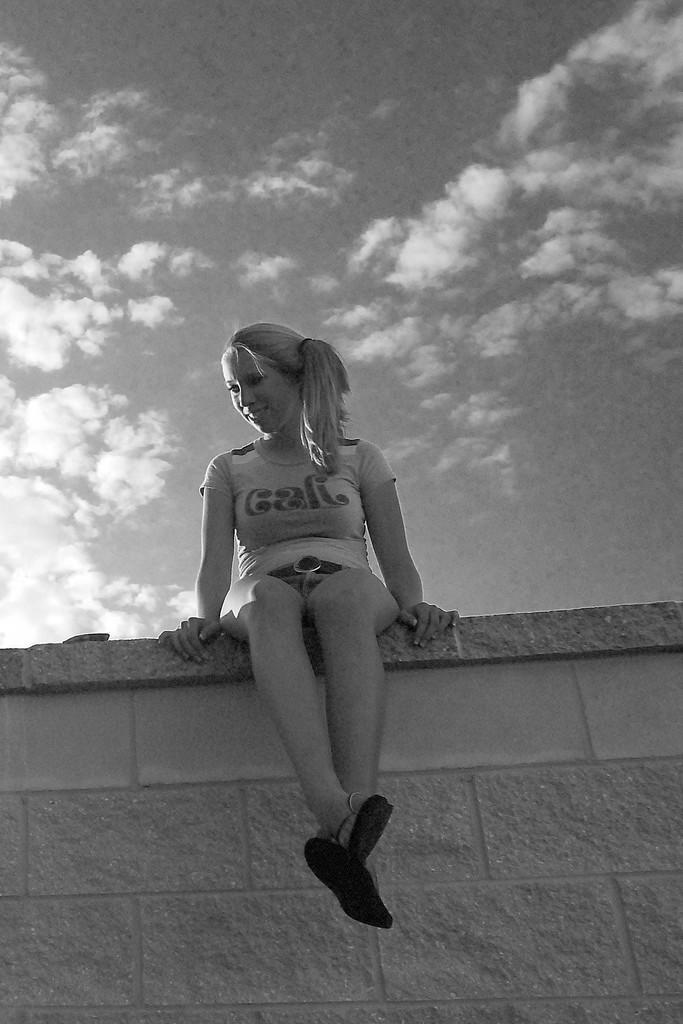Please provide a concise description of this image. In this picture I can see the wall in front on which I see a girl who is sitting and I see that she is smiling. In the background I see the sky. I can see that this is a white and black picture. 